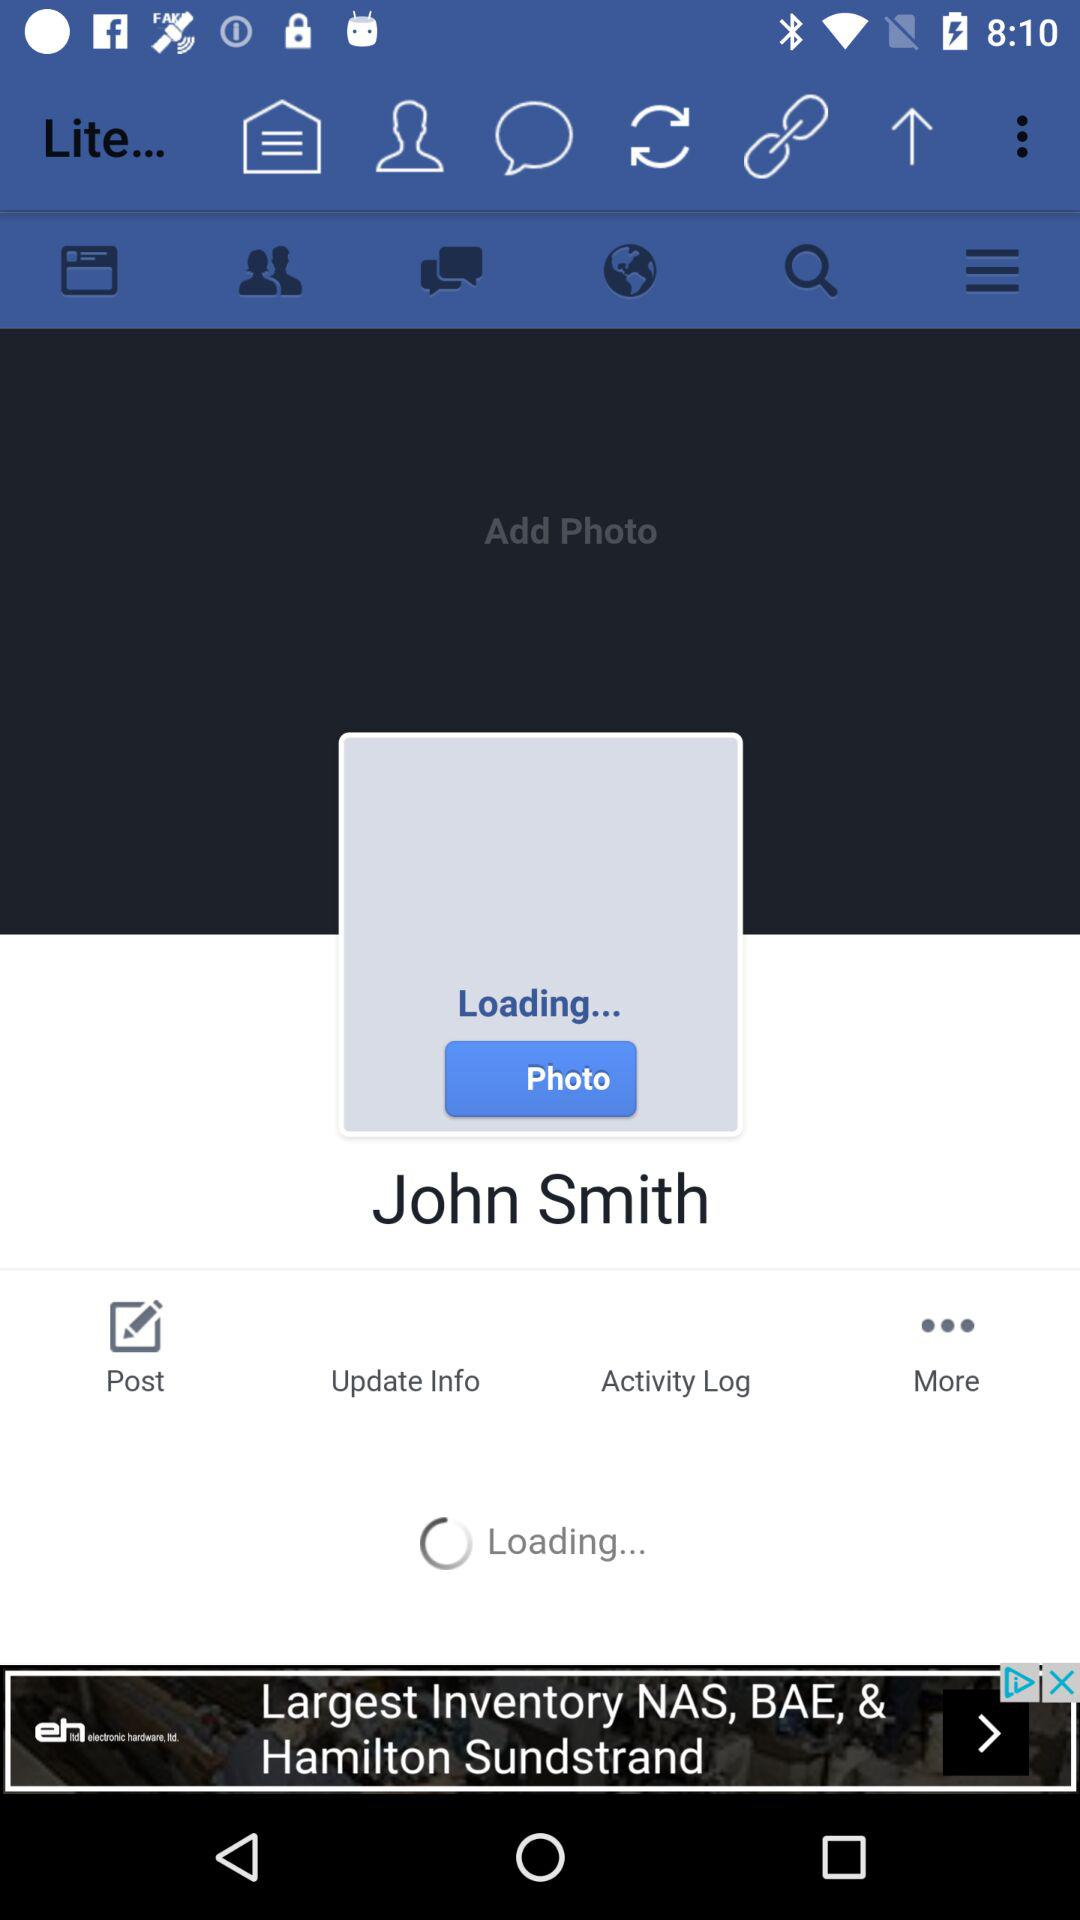What is the user name? The user name is John Smith. 